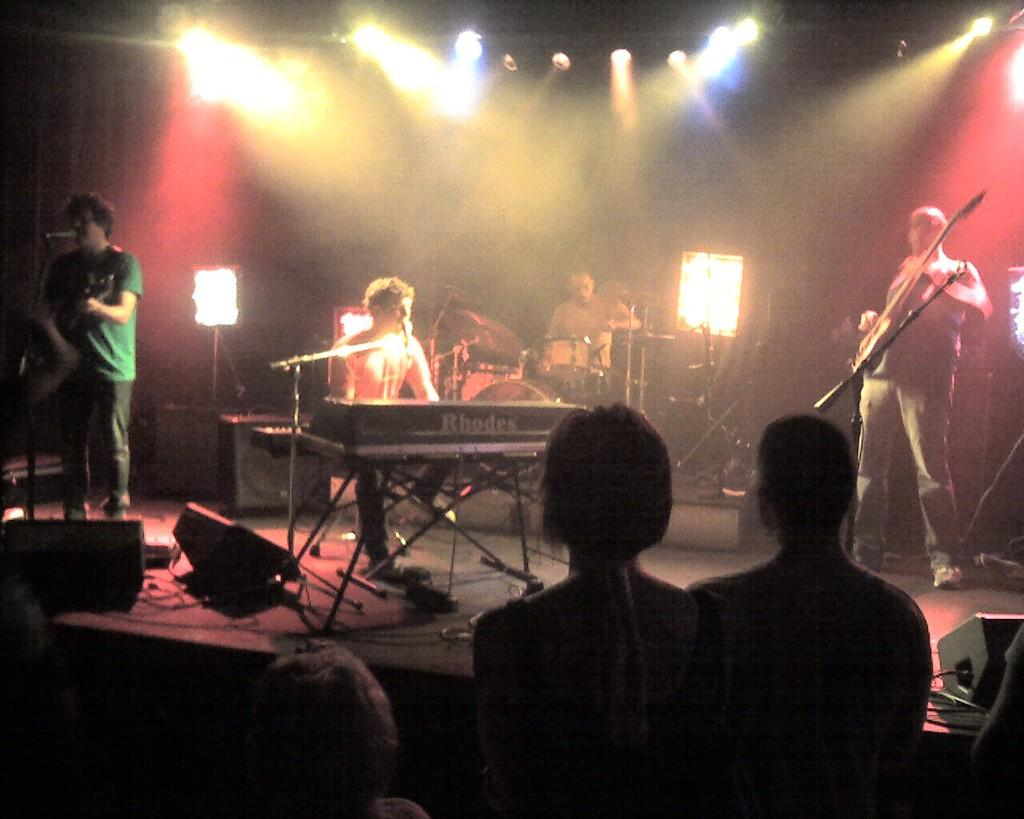How many musicians are playing in the image? There are four people playing musical instruments in the image. Are there any other people present besides the musicians? Yes, there are three people in front of the musicians. What can be seen in the background of the image? There are lights visible in the background of the image. What type of property is being discussed by the musicians in the image? There is no discussion of property in the image; it features musicians playing their instruments and people standing in front of them. 